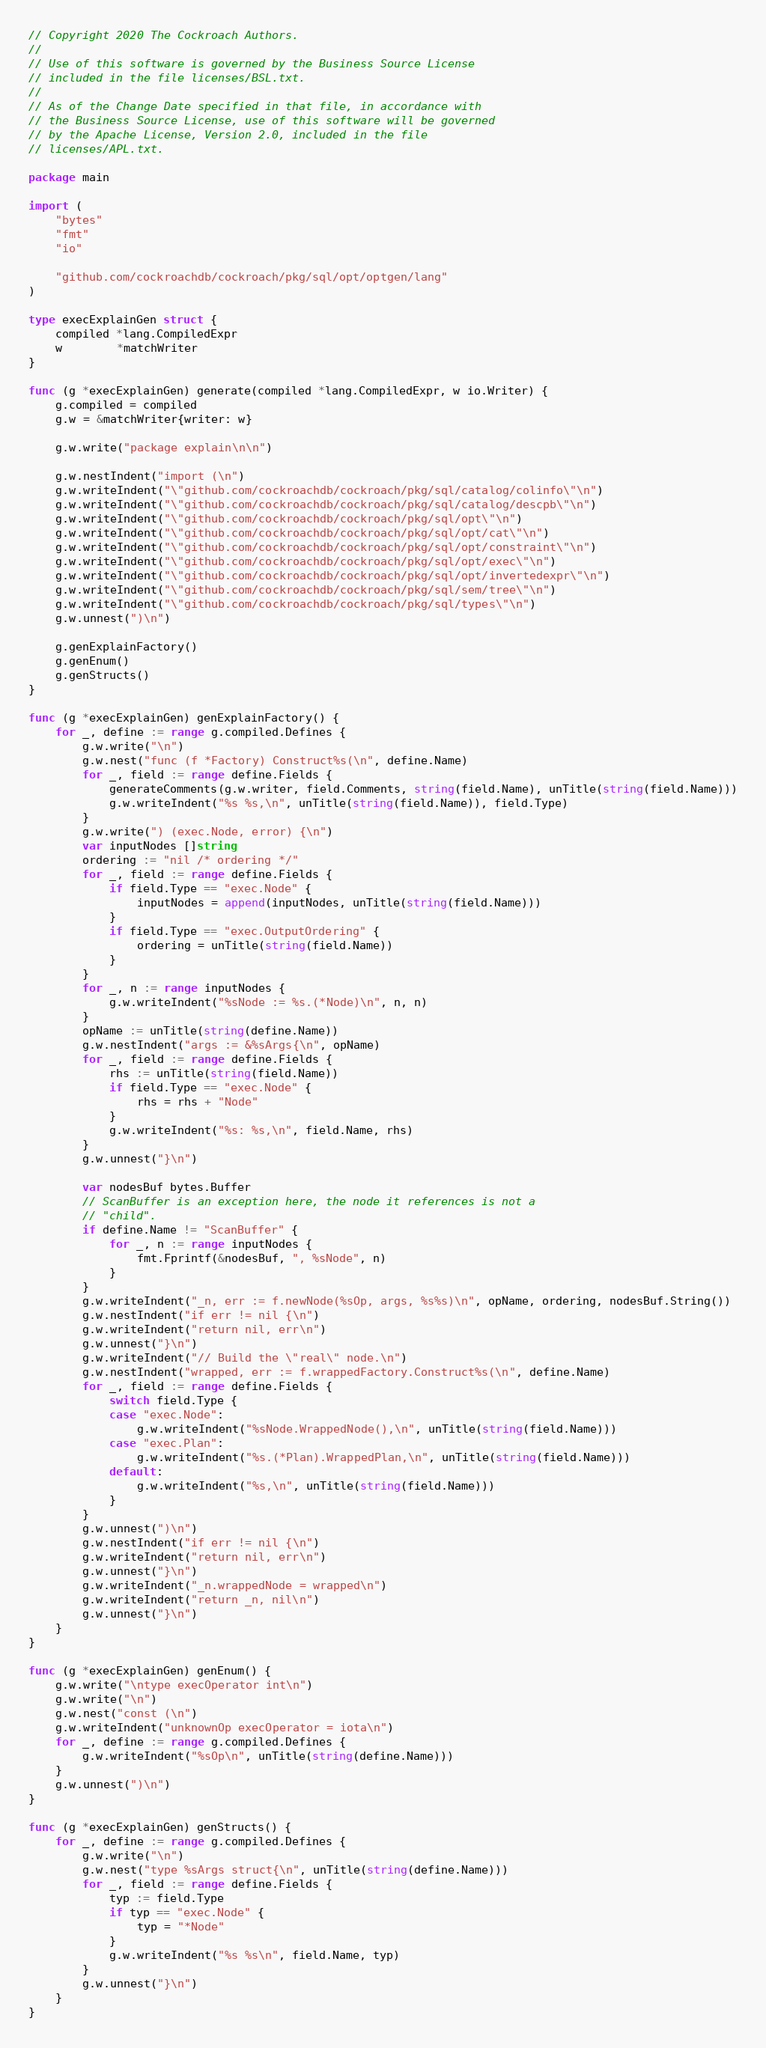Convert code to text. <code><loc_0><loc_0><loc_500><loc_500><_Go_>// Copyright 2020 The Cockroach Authors.
//
// Use of this software is governed by the Business Source License
// included in the file licenses/BSL.txt.
//
// As of the Change Date specified in that file, in accordance with
// the Business Source License, use of this software will be governed
// by the Apache License, Version 2.0, included in the file
// licenses/APL.txt.

package main

import (
	"bytes"
	"fmt"
	"io"

	"github.com/cockroachdb/cockroach/pkg/sql/opt/optgen/lang"
)

type execExplainGen struct {
	compiled *lang.CompiledExpr
	w        *matchWriter
}

func (g *execExplainGen) generate(compiled *lang.CompiledExpr, w io.Writer) {
	g.compiled = compiled
	g.w = &matchWriter{writer: w}

	g.w.write("package explain\n\n")

	g.w.nestIndent("import (\n")
	g.w.writeIndent("\"github.com/cockroachdb/cockroach/pkg/sql/catalog/colinfo\"\n")
	g.w.writeIndent("\"github.com/cockroachdb/cockroach/pkg/sql/catalog/descpb\"\n")
	g.w.writeIndent("\"github.com/cockroachdb/cockroach/pkg/sql/opt\"\n")
	g.w.writeIndent("\"github.com/cockroachdb/cockroach/pkg/sql/opt/cat\"\n")
	g.w.writeIndent("\"github.com/cockroachdb/cockroach/pkg/sql/opt/constraint\"\n")
	g.w.writeIndent("\"github.com/cockroachdb/cockroach/pkg/sql/opt/exec\"\n")
	g.w.writeIndent("\"github.com/cockroachdb/cockroach/pkg/sql/opt/invertedexpr\"\n")
	g.w.writeIndent("\"github.com/cockroachdb/cockroach/pkg/sql/sem/tree\"\n")
	g.w.writeIndent("\"github.com/cockroachdb/cockroach/pkg/sql/types\"\n")
	g.w.unnest(")\n")

	g.genExplainFactory()
	g.genEnum()
	g.genStructs()
}

func (g *execExplainGen) genExplainFactory() {
	for _, define := range g.compiled.Defines {
		g.w.write("\n")
		g.w.nest("func (f *Factory) Construct%s(\n", define.Name)
		for _, field := range define.Fields {
			generateComments(g.w.writer, field.Comments, string(field.Name), unTitle(string(field.Name)))
			g.w.writeIndent("%s %s,\n", unTitle(string(field.Name)), field.Type)
		}
		g.w.write(") (exec.Node, error) {\n")
		var inputNodes []string
		ordering := "nil /* ordering */"
		for _, field := range define.Fields {
			if field.Type == "exec.Node" {
				inputNodes = append(inputNodes, unTitle(string(field.Name)))
			}
			if field.Type == "exec.OutputOrdering" {
				ordering = unTitle(string(field.Name))
			}
		}
		for _, n := range inputNodes {
			g.w.writeIndent("%sNode := %s.(*Node)\n", n, n)
		}
		opName := unTitle(string(define.Name))
		g.w.nestIndent("args := &%sArgs{\n", opName)
		for _, field := range define.Fields {
			rhs := unTitle(string(field.Name))
			if field.Type == "exec.Node" {
				rhs = rhs + "Node"
			}
			g.w.writeIndent("%s: %s,\n", field.Name, rhs)
		}
		g.w.unnest("}\n")

		var nodesBuf bytes.Buffer
		// ScanBuffer is an exception here, the node it references is not a
		// "child".
		if define.Name != "ScanBuffer" {
			for _, n := range inputNodes {
				fmt.Fprintf(&nodesBuf, ", %sNode", n)
			}
		}
		g.w.writeIndent("_n, err := f.newNode(%sOp, args, %s%s)\n", opName, ordering, nodesBuf.String())
		g.w.nestIndent("if err != nil {\n")
		g.w.writeIndent("return nil, err\n")
		g.w.unnest("}\n")
		g.w.writeIndent("// Build the \"real\" node.\n")
		g.w.nestIndent("wrapped, err := f.wrappedFactory.Construct%s(\n", define.Name)
		for _, field := range define.Fields {
			switch field.Type {
			case "exec.Node":
				g.w.writeIndent("%sNode.WrappedNode(),\n", unTitle(string(field.Name)))
			case "exec.Plan":
				g.w.writeIndent("%s.(*Plan).WrappedPlan,\n", unTitle(string(field.Name)))
			default:
				g.w.writeIndent("%s,\n", unTitle(string(field.Name)))
			}
		}
		g.w.unnest(")\n")
		g.w.nestIndent("if err != nil {\n")
		g.w.writeIndent("return nil, err\n")
		g.w.unnest("}\n")
		g.w.writeIndent("_n.wrappedNode = wrapped\n")
		g.w.writeIndent("return _n, nil\n")
		g.w.unnest("}\n")
	}
}

func (g *execExplainGen) genEnum() {
	g.w.write("\ntype execOperator int\n")
	g.w.write("\n")
	g.w.nest("const (\n")
	g.w.writeIndent("unknownOp execOperator = iota\n")
	for _, define := range g.compiled.Defines {
		g.w.writeIndent("%sOp\n", unTitle(string(define.Name)))
	}
	g.w.unnest(")\n")
}

func (g *execExplainGen) genStructs() {
	for _, define := range g.compiled.Defines {
		g.w.write("\n")
		g.w.nest("type %sArgs struct{\n", unTitle(string(define.Name)))
		for _, field := range define.Fields {
			typ := field.Type
			if typ == "exec.Node" {
				typ = "*Node"
			}
			g.w.writeIndent("%s %s\n", field.Name, typ)
		}
		g.w.unnest("}\n")
	}
}
</code> 